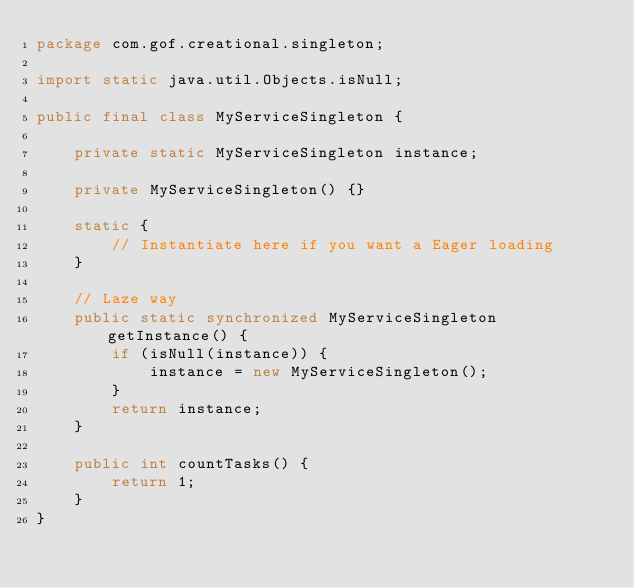<code> <loc_0><loc_0><loc_500><loc_500><_Java_>package com.gof.creational.singleton;

import static java.util.Objects.isNull;

public final class MyServiceSingleton {

    private static MyServiceSingleton instance;

    private MyServiceSingleton() {}

    static {
        // Instantiate here if you want a Eager loading
    }

    // Laze way
    public static synchronized MyServiceSingleton getInstance() {
        if (isNull(instance)) {
            instance = new MyServiceSingleton();
        }
        return instance;
    }

    public int countTasks() {
        return 1;
    }
}
</code> 